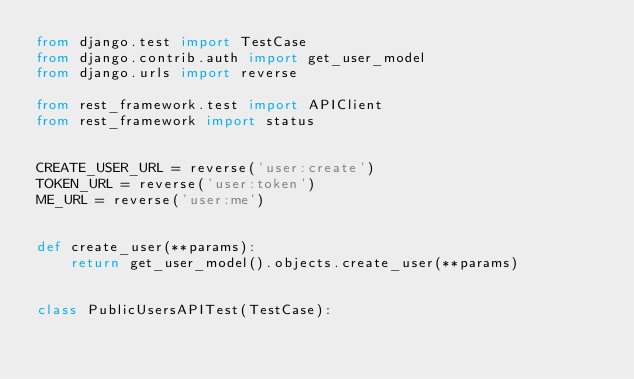<code> <loc_0><loc_0><loc_500><loc_500><_Python_>from django.test import TestCase
from django.contrib.auth import get_user_model
from django.urls import reverse

from rest_framework.test import APIClient
from rest_framework import status


CREATE_USER_URL = reverse('user:create')
TOKEN_URL = reverse('user:token')
ME_URL = reverse('user:me')


def create_user(**params):
    return get_user_model().objects.create_user(**params)


class PublicUsersAPITest(TestCase):</code> 